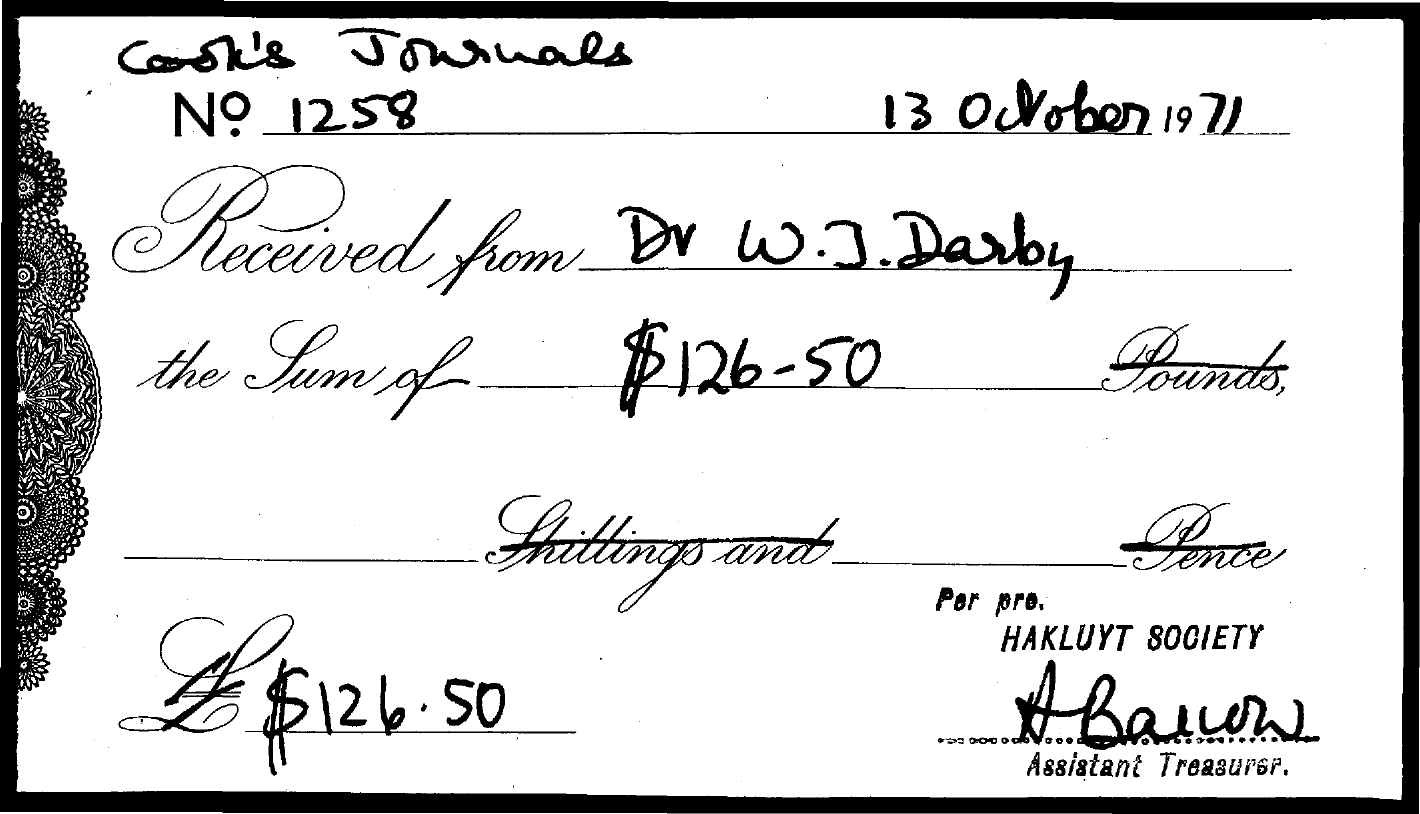What is the sum amount mentioned in given document?
Offer a very short reply. $126.50. What is the cook's journals number mentioned in the given document?
Give a very brief answer. 1258. What is the date mentioned in the document?
Provide a short and direct response. 13 October 1971. 